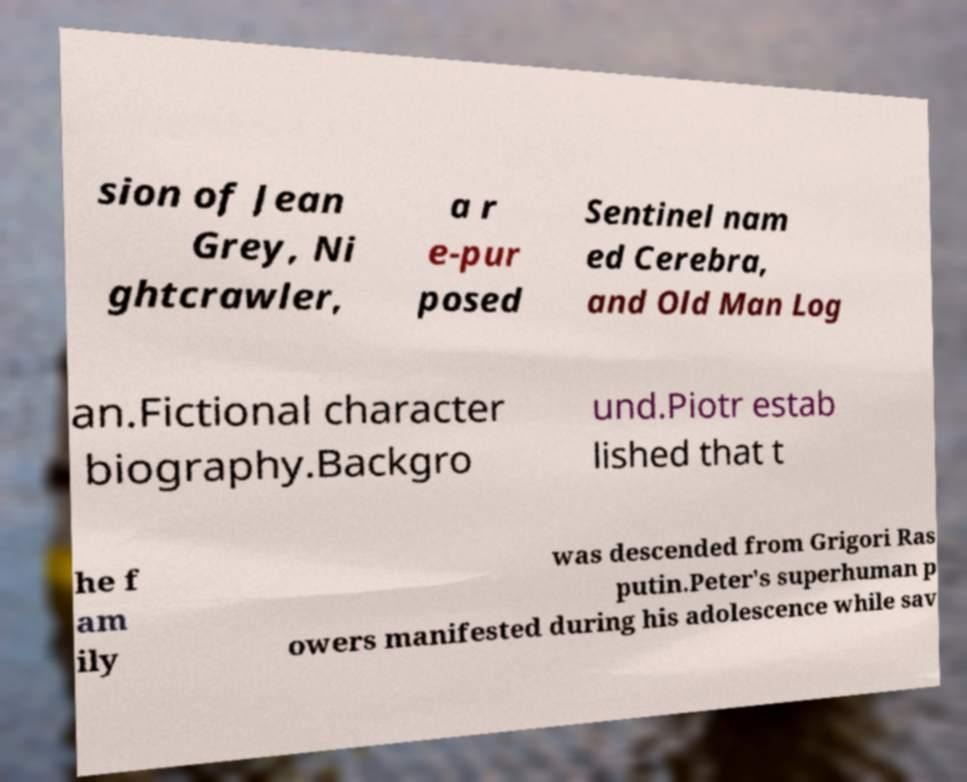For documentation purposes, I need the text within this image transcribed. Could you provide that? sion of Jean Grey, Ni ghtcrawler, a r e-pur posed Sentinel nam ed Cerebra, and Old Man Log an.Fictional character biography.Backgro und.Piotr estab lished that t he f am ily was descended from Grigori Ras putin.Peter's superhuman p owers manifested during his adolescence while sav 